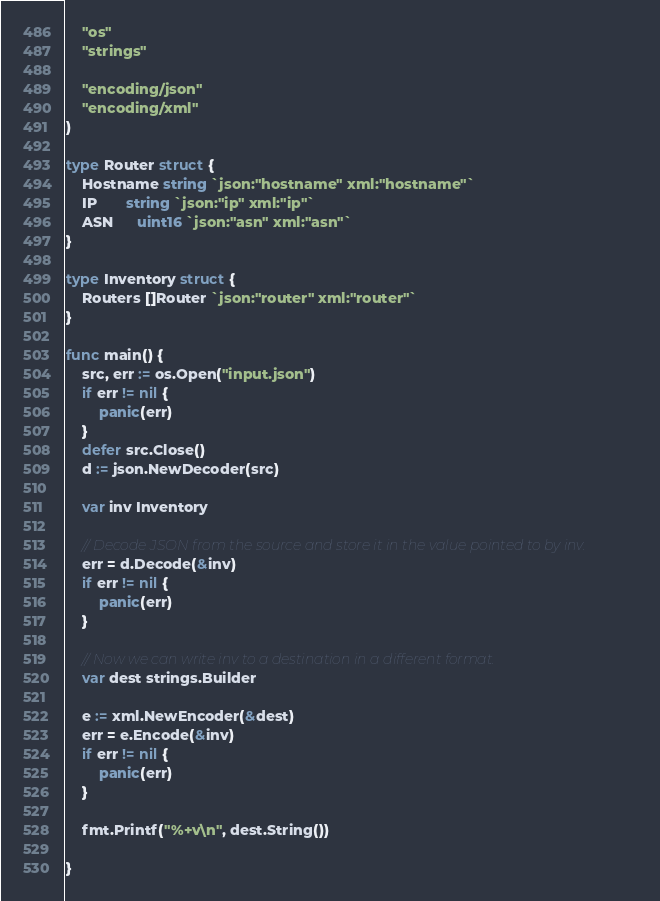<code> <loc_0><loc_0><loc_500><loc_500><_Go_>	"os"
	"strings"

	"encoding/json"
	"encoding/xml"
)

type Router struct {
	Hostname string `json:"hostname" xml:"hostname"`
	IP       string `json:"ip" xml:"ip"`
	ASN      uint16 `json:"asn" xml:"asn"`
}

type Inventory struct {
	Routers []Router `json:"router" xml:"router"`
}

func main() {
	src, err := os.Open("input.json")
	if err != nil {
		panic(err)
	}
	defer src.Close()
	d := json.NewDecoder(src)

	var inv Inventory

	// Decode JSON from the source and store it in the value pointed to by inv.
	err = d.Decode(&inv)
	if err != nil {
		panic(err)
	}

	// Now we can write inv to a destination in a different format.
	var dest strings.Builder

	e := xml.NewEncoder(&dest)
	err = e.Encode(&inv)
	if err != nil {
		panic(err)
	}

	fmt.Printf("%+v\n", dest.String())

}
</code> 